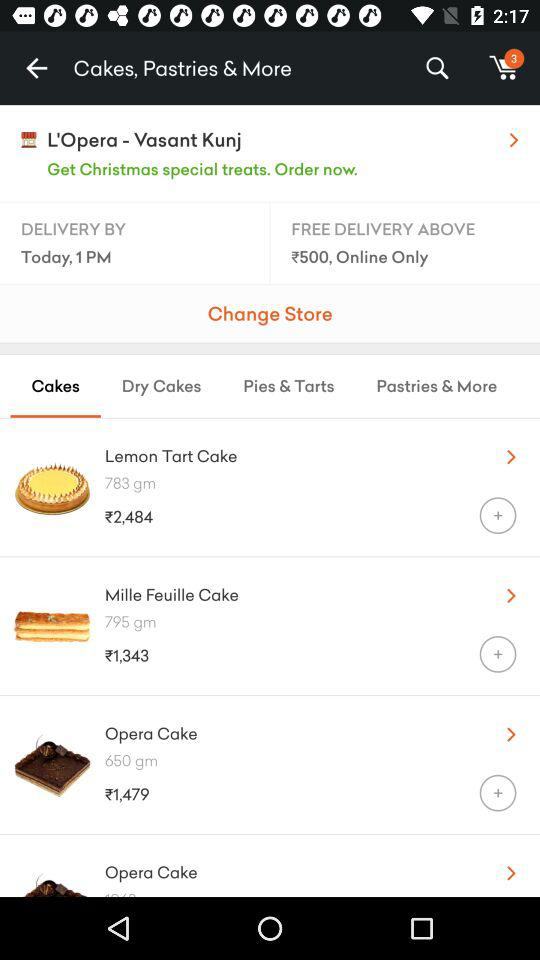What is the weight of the "Lemon Tart Cake"? The weight of the "Lemon Tart Cake" is 783 grams. 